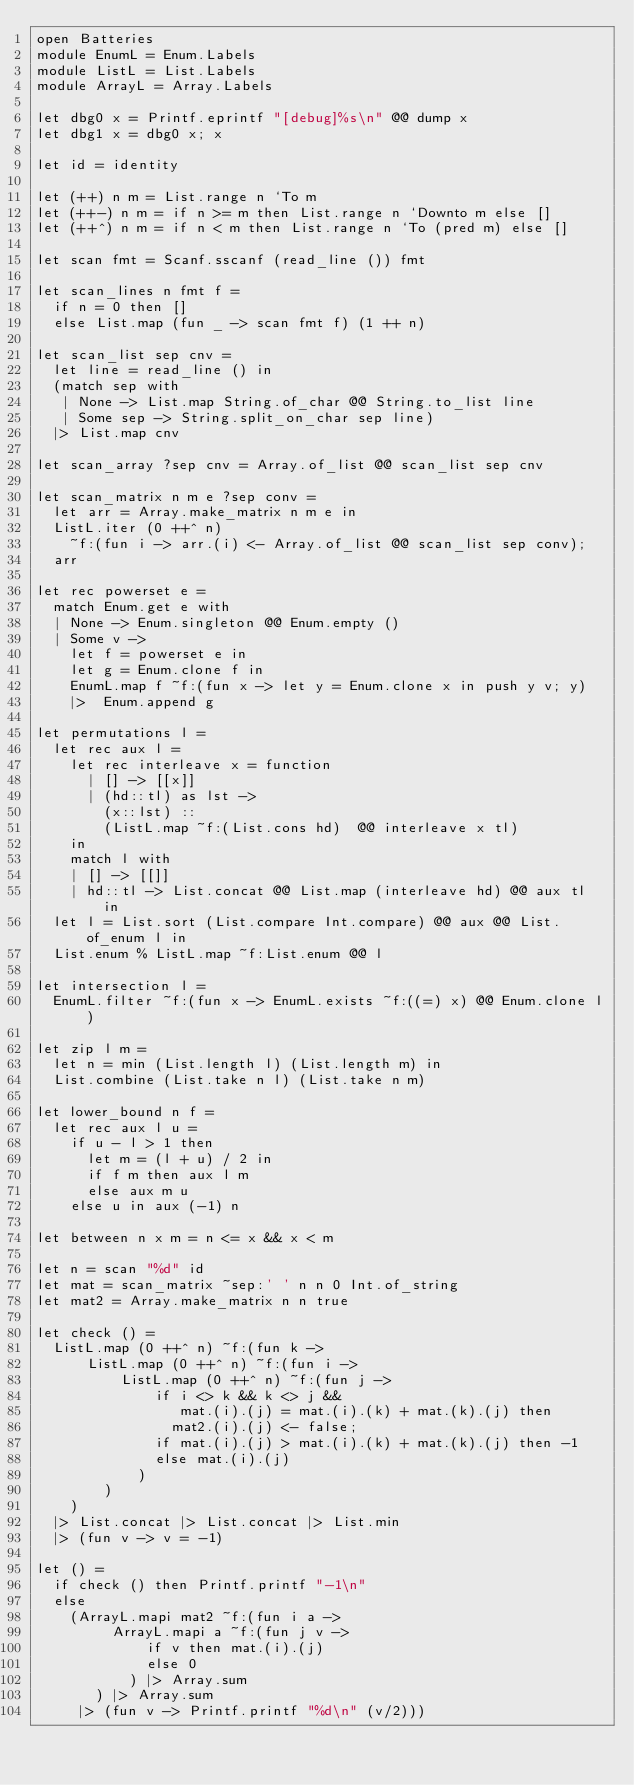<code> <loc_0><loc_0><loc_500><loc_500><_OCaml_>open Batteries
module EnumL = Enum.Labels
module ListL = List.Labels
module ArrayL = Array.Labels

let dbg0 x = Printf.eprintf "[debug]%s\n" @@ dump x
let dbg1 x = dbg0 x; x

let id = identity

let (++) n m = List.range n `To m
let (++-) n m = if n >= m then List.range n `Downto m else []
let (++^) n m = if n < m then List.range n `To (pred m) else []

let scan fmt = Scanf.sscanf (read_line ()) fmt

let scan_lines n fmt f =
  if n = 0 then []
  else List.map (fun _ -> scan fmt f) (1 ++ n)

let scan_list sep cnv =
  let line = read_line () in
  (match sep with
   | None -> List.map String.of_char @@ String.to_list line
   | Some sep -> String.split_on_char sep line)
  |> List.map cnv

let scan_array ?sep cnv = Array.of_list @@ scan_list sep cnv

let scan_matrix n m e ?sep conv =
  let arr = Array.make_matrix n m e in
  ListL.iter (0 ++^ n)
    ~f:(fun i -> arr.(i) <- Array.of_list @@ scan_list sep conv);
  arr

let rec powerset e =
  match Enum.get e with
  | None -> Enum.singleton @@ Enum.empty ()
  | Some v ->
    let f = powerset e in
    let g = Enum.clone f in
    EnumL.map f ~f:(fun x -> let y = Enum.clone x in push y v; y)
    |>  Enum.append g

let permutations l =
  let rec aux l =
    let rec interleave x = function
      | [] -> [[x]]
      | (hd::tl) as lst ->
        (x::lst) ::
        (ListL.map ~f:(List.cons hd)  @@ interleave x tl)
    in
    match l with
    | [] -> [[]]
    | hd::tl -> List.concat @@ List.map (interleave hd) @@ aux tl in
  let l = List.sort (List.compare Int.compare) @@ aux @@ List.of_enum l in
  List.enum % ListL.map ~f:List.enum @@ l

let intersection l =
  EnumL.filter ~f:(fun x -> EnumL.exists ~f:((=) x) @@ Enum.clone l)

let zip l m =
  let n = min (List.length l) (List.length m) in
  List.combine (List.take n l) (List.take n m)

let lower_bound n f =
  let rec aux l u =
    if u - l > 1 then
      let m = (l + u) / 2 in
      if f m then aux l m
      else aux m u
    else u in aux (-1) n

let between n x m = n <= x && x < m

let n = scan "%d" id
let mat = scan_matrix ~sep:' ' n n 0 Int.of_string
let mat2 = Array.make_matrix n n true

let check () =
  ListL.map (0 ++^ n) ~f:(fun k ->
      ListL.map (0 ++^ n) ~f:(fun i ->
          ListL.map (0 ++^ n) ~f:(fun j ->
              if i <> k && k <> j &&
                 mat.(i).(j) = mat.(i).(k) + mat.(k).(j) then
                mat2.(i).(j) <- false;
              if mat.(i).(j) > mat.(i).(k) + mat.(k).(j) then -1
              else mat.(i).(j)
            )
        )
    )
  |> List.concat |> List.concat |> List.min
  |> (fun v -> v = -1)

let () =
  if check () then Printf.printf "-1\n"
  else
    (ArrayL.mapi mat2 ~f:(fun i a ->
         ArrayL.mapi a ~f:(fun j v ->
             if v then mat.(i).(j)
             else 0
           ) |> Array.sum
       ) |> Array.sum
     |> (fun v -> Printf.printf "%d\n" (v/2)))
</code> 